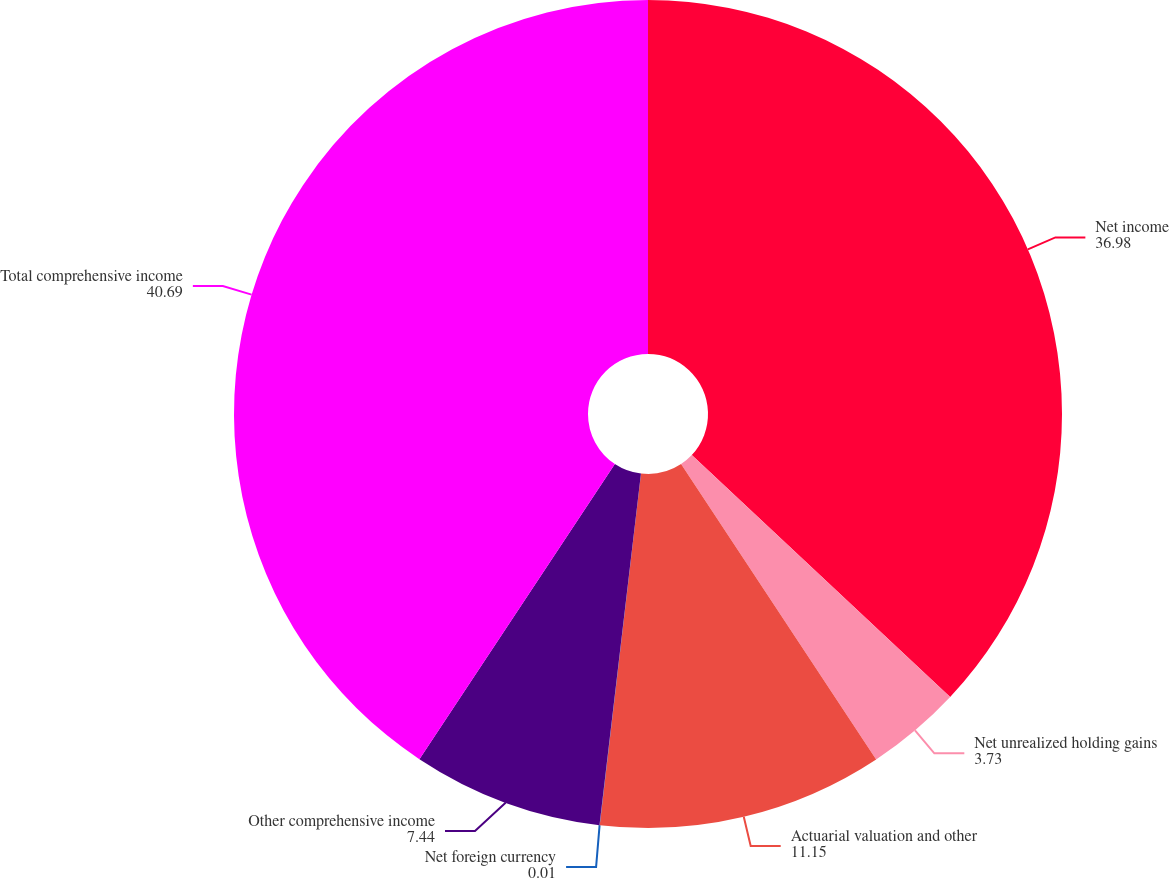<chart> <loc_0><loc_0><loc_500><loc_500><pie_chart><fcel>Net income<fcel>Net unrealized holding gains<fcel>Actuarial valuation and other<fcel>Net foreign currency<fcel>Other comprehensive income<fcel>Total comprehensive income<nl><fcel>36.98%<fcel>3.73%<fcel>11.15%<fcel>0.01%<fcel>7.44%<fcel>40.69%<nl></chart> 